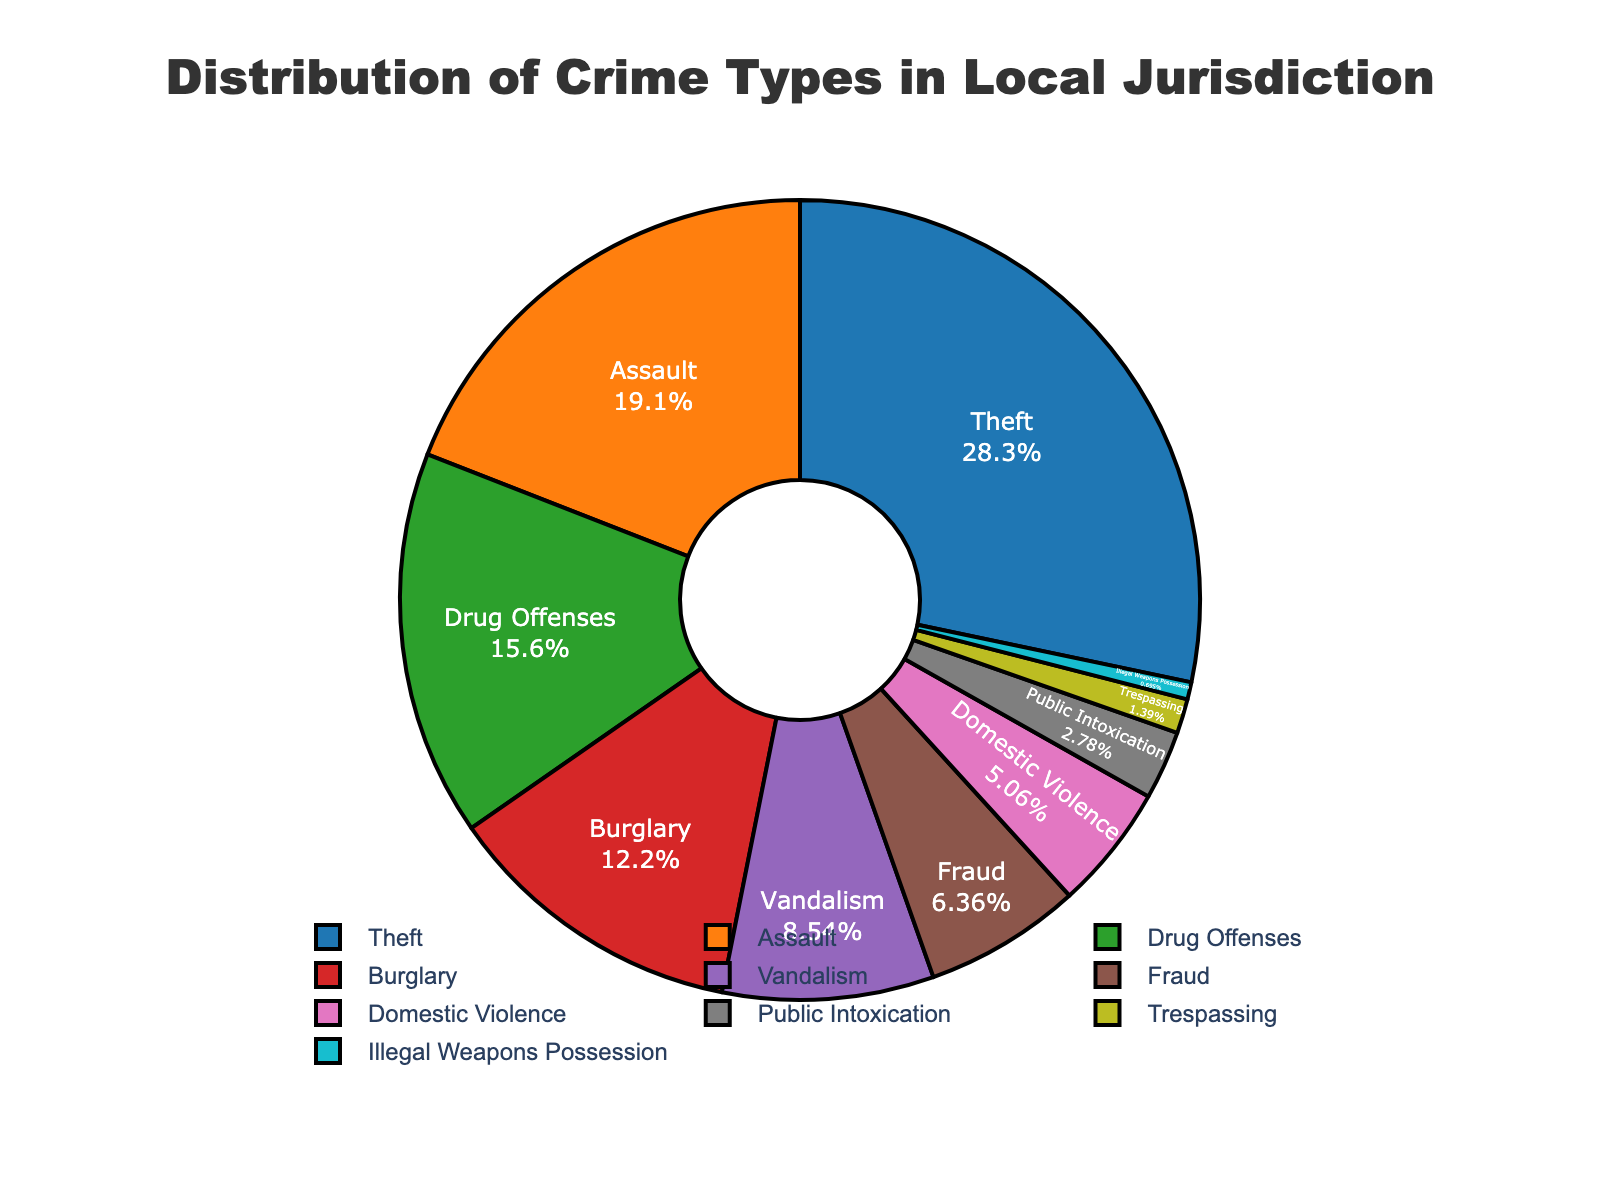Which crime type has the highest percentage? The figure shows the distribution of crime types with Theft having the largest section of the pie chart.
Answer: Theft Which crime type has a lower percentage: Vandalism or Domestic Violence? By comparing the sizes of the sections in the pie chart, Vandalism has a larger slice than Domestic Violence.
Answer: Domestic Violence What is the total percentage of Drug Offenses, Burglary, and Fraud combined? Add the percentages of Drug Offenses (15.7%), Burglary (12.3%), and Fraud (6.4%). The total is 15.7 + 12.3 + 6.4 = 34.4%.
Answer: 34.4% How much more prevalent is Theft compared to Assault? Subtract the percentage of Assault (19.2%) from Theft (28.5%). 28.5 - 19.2 = 9.3%.
Answer: 9.3% Which crime type is represented by the smallest section of the pie chart? The smallest section of the pie chart corresponds to the crime type Illegal Weapons Possession.
Answer: Illegal Weapons Possession What is the combined percentage of theft-related crimes (Theft and Burglary)? Add the percentages of Theft (28.5%) and Burglary (12.3%). The total is 28.5 + 12.3 = 40.8%.
Answer: 40.8% Are there more cases of Fraud or Public Intoxication? By comparing the sections in the pie chart, Fraud (6.4%) has a larger percentage than Public Intoxication (2.8%).
Answer: Fraud How much lesser is the percentage of Vandalism compared to Drug Offenses? Subtract the percentage of Drug Offenses (15.7%) from Vandalism (8.6%). 15.7 - 8.6 = 7.1%.
Answer: 7.1% What two crime types together make up just over 50% of the crime types shown? By adding the percentages, Theft (28.5%) and Assault (19.2%) together make 28.5 + 19.2 = 47.7%, which is close but not over. Adding Drug Offenses (15.7%) and Burglary (12.3%) to Theft's 28.5%, we get above 50%. So Theft, plus either Drug Offenses or Burglary, is not sufficient. However, including Vandalism's 8.6% with Theft and Assault, it totals over 50%. The exact pair is a combination of more than two.
Answer: (Theft, Assault) with addition of Drug Offenses or Burglary Which color represents Domestic Violence in the pie chart? The section of the pie chart labeled Domestic Violence is colored to visualize the data.
Answer: (Answer visually identified from the pie chart) 